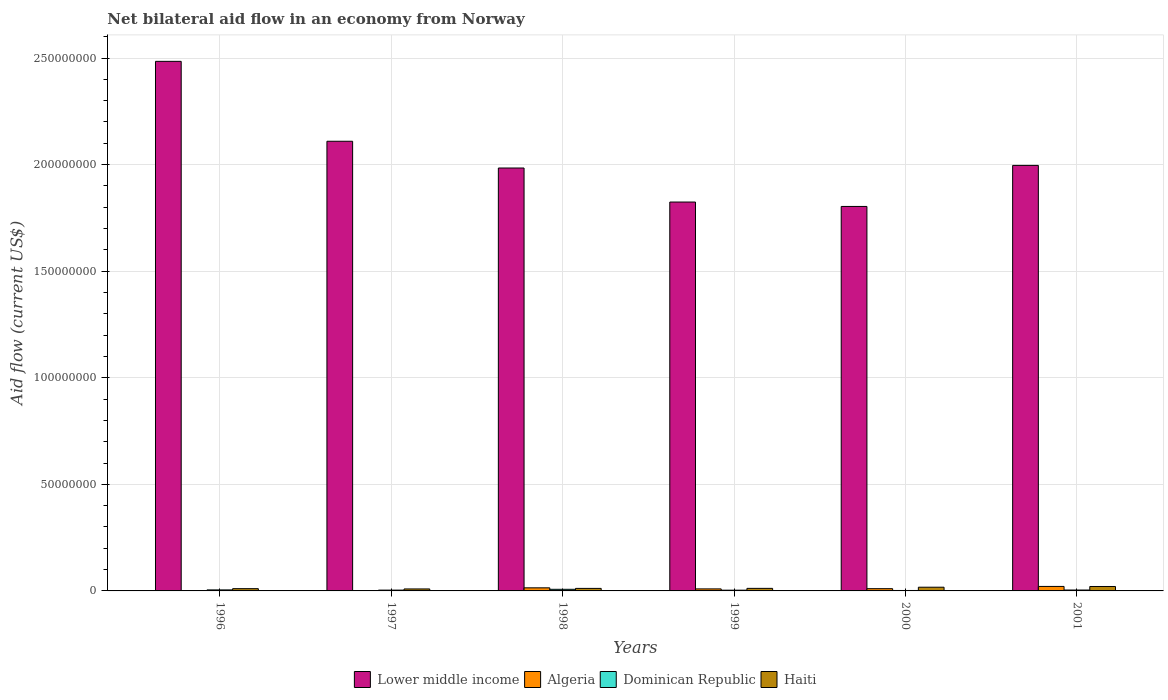How many groups of bars are there?
Your answer should be compact. 6. Are the number of bars per tick equal to the number of legend labels?
Make the answer very short. Yes. How many bars are there on the 6th tick from the left?
Give a very brief answer. 4. What is the label of the 2nd group of bars from the left?
Give a very brief answer. 1997. In how many cases, is the number of bars for a given year not equal to the number of legend labels?
Your answer should be very brief. 0. What is the net bilateral aid flow in Haiti in 1999?
Your response must be concise. 1.20e+06. Across all years, what is the maximum net bilateral aid flow in Haiti?
Make the answer very short. 2.08e+06. In which year was the net bilateral aid flow in Haiti maximum?
Keep it short and to the point. 2001. What is the total net bilateral aid flow in Lower middle income in the graph?
Offer a terse response. 1.22e+09. What is the difference between the net bilateral aid flow in Lower middle income in 1997 and that in 1998?
Keep it short and to the point. 1.26e+07. What is the difference between the net bilateral aid flow in Lower middle income in 2000 and the net bilateral aid flow in Algeria in 1998?
Your answer should be very brief. 1.79e+08. What is the average net bilateral aid flow in Lower middle income per year?
Your answer should be compact. 2.03e+08. In the year 1998, what is the difference between the net bilateral aid flow in Lower middle income and net bilateral aid flow in Haiti?
Ensure brevity in your answer.  1.97e+08. In how many years, is the net bilateral aid flow in Haiti greater than 150000000 US$?
Offer a terse response. 0. What is the ratio of the net bilateral aid flow in Lower middle income in 1997 to that in 1998?
Ensure brevity in your answer.  1.06. What is the difference between the highest and the second highest net bilateral aid flow in Algeria?
Offer a terse response. 6.60e+05. What is the difference between the highest and the lowest net bilateral aid flow in Algeria?
Offer a terse response. 2.01e+06. In how many years, is the net bilateral aid flow in Algeria greater than the average net bilateral aid flow in Algeria taken over all years?
Offer a terse response. 3. What does the 4th bar from the left in 1997 represents?
Provide a short and direct response. Haiti. What does the 3rd bar from the right in 1998 represents?
Ensure brevity in your answer.  Algeria. How many bars are there?
Give a very brief answer. 24. Are all the bars in the graph horizontal?
Offer a very short reply. No. Are the values on the major ticks of Y-axis written in scientific E-notation?
Your answer should be very brief. No. Does the graph contain any zero values?
Ensure brevity in your answer.  No. Does the graph contain grids?
Provide a succinct answer. Yes. How are the legend labels stacked?
Your response must be concise. Horizontal. What is the title of the graph?
Keep it short and to the point. Net bilateral aid flow in an economy from Norway. What is the label or title of the X-axis?
Your answer should be very brief. Years. What is the label or title of the Y-axis?
Keep it short and to the point. Aid flow (current US$). What is the Aid flow (current US$) in Lower middle income in 1996?
Make the answer very short. 2.48e+08. What is the Aid flow (current US$) of Dominican Republic in 1996?
Your answer should be very brief. 4.80e+05. What is the Aid flow (current US$) in Haiti in 1996?
Give a very brief answer. 1.06e+06. What is the Aid flow (current US$) in Lower middle income in 1997?
Give a very brief answer. 2.11e+08. What is the Aid flow (current US$) in Dominican Republic in 1997?
Provide a succinct answer. 3.80e+05. What is the Aid flow (current US$) in Haiti in 1997?
Keep it short and to the point. 9.30e+05. What is the Aid flow (current US$) in Lower middle income in 1998?
Your answer should be compact. 1.98e+08. What is the Aid flow (current US$) of Algeria in 1998?
Make the answer very short. 1.45e+06. What is the Aid flow (current US$) of Dominican Republic in 1998?
Your answer should be very brief. 7.60e+05. What is the Aid flow (current US$) in Haiti in 1998?
Offer a very short reply. 1.18e+06. What is the Aid flow (current US$) of Lower middle income in 1999?
Offer a very short reply. 1.82e+08. What is the Aid flow (current US$) in Algeria in 1999?
Provide a short and direct response. 9.50e+05. What is the Aid flow (current US$) in Haiti in 1999?
Keep it short and to the point. 1.20e+06. What is the Aid flow (current US$) of Lower middle income in 2000?
Make the answer very short. 1.80e+08. What is the Aid flow (current US$) of Algeria in 2000?
Ensure brevity in your answer.  1.05e+06. What is the Aid flow (current US$) in Dominican Republic in 2000?
Your response must be concise. 2.10e+05. What is the Aid flow (current US$) in Haiti in 2000?
Make the answer very short. 1.74e+06. What is the Aid flow (current US$) of Lower middle income in 2001?
Ensure brevity in your answer.  2.00e+08. What is the Aid flow (current US$) of Algeria in 2001?
Provide a short and direct response. 2.11e+06. What is the Aid flow (current US$) in Dominican Republic in 2001?
Offer a terse response. 4.20e+05. What is the Aid flow (current US$) in Haiti in 2001?
Provide a short and direct response. 2.08e+06. Across all years, what is the maximum Aid flow (current US$) of Lower middle income?
Keep it short and to the point. 2.48e+08. Across all years, what is the maximum Aid flow (current US$) of Algeria?
Keep it short and to the point. 2.11e+06. Across all years, what is the maximum Aid flow (current US$) in Dominican Republic?
Keep it short and to the point. 7.60e+05. Across all years, what is the maximum Aid flow (current US$) of Haiti?
Your answer should be compact. 2.08e+06. Across all years, what is the minimum Aid flow (current US$) in Lower middle income?
Your answer should be compact. 1.80e+08. Across all years, what is the minimum Aid flow (current US$) of Algeria?
Make the answer very short. 1.00e+05. Across all years, what is the minimum Aid flow (current US$) in Haiti?
Your answer should be compact. 9.30e+05. What is the total Aid flow (current US$) of Lower middle income in the graph?
Offer a very short reply. 1.22e+09. What is the total Aid flow (current US$) in Algeria in the graph?
Provide a short and direct response. 5.81e+06. What is the total Aid flow (current US$) in Dominican Republic in the graph?
Offer a very short reply. 2.60e+06. What is the total Aid flow (current US$) of Haiti in the graph?
Keep it short and to the point. 8.19e+06. What is the difference between the Aid flow (current US$) of Lower middle income in 1996 and that in 1997?
Keep it short and to the point. 3.75e+07. What is the difference between the Aid flow (current US$) in Algeria in 1996 and that in 1997?
Your answer should be very brief. 5.00e+04. What is the difference between the Aid flow (current US$) of Dominican Republic in 1996 and that in 1997?
Your answer should be compact. 1.00e+05. What is the difference between the Aid flow (current US$) of Haiti in 1996 and that in 1997?
Your response must be concise. 1.30e+05. What is the difference between the Aid flow (current US$) in Lower middle income in 1996 and that in 1998?
Offer a very short reply. 5.00e+07. What is the difference between the Aid flow (current US$) in Algeria in 1996 and that in 1998?
Offer a terse response. -1.30e+06. What is the difference between the Aid flow (current US$) of Dominican Republic in 1996 and that in 1998?
Provide a succinct answer. -2.80e+05. What is the difference between the Aid flow (current US$) of Lower middle income in 1996 and that in 1999?
Offer a very short reply. 6.60e+07. What is the difference between the Aid flow (current US$) of Algeria in 1996 and that in 1999?
Offer a terse response. -8.00e+05. What is the difference between the Aid flow (current US$) of Dominican Republic in 1996 and that in 1999?
Your answer should be compact. 1.30e+05. What is the difference between the Aid flow (current US$) in Haiti in 1996 and that in 1999?
Your answer should be very brief. -1.40e+05. What is the difference between the Aid flow (current US$) in Lower middle income in 1996 and that in 2000?
Ensure brevity in your answer.  6.81e+07. What is the difference between the Aid flow (current US$) in Algeria in 1996 and that in 2000?
Ensure brevity in your answer.  -9.00e+05. What is the difference between the Aid flow (current US$) of Haiti in 1996 and that in 2000?
Provide a short and direct response. -6.80e+05. What is the difference between the Aid flow (current US$) of Lower middle income in 1996 and that in 2001?
Ensure brevity in your answer.  4.88e+07. What is the difference between the Aid flow (current US$) of Algeria in 1996 and that in 2001?
Give a very brief answer. -1.96e+06. What is the difference between the Aid flow (current US$) of Haiti in 1996 and that in 2001?
Provide a succinct answer. -1.02e+06. What is the difference between the Aid flow (current US$) in Lower middle income in 1997 and that in 1998?
Give a very brief answer. 1.26e+07. What is the difference between the Aid flow (current US$) in Algeria in 1997 and that in 1998?
Offer a terse response. -1.35e+06. What is the difference between the Aid flow (current US$) of Dominican Republic in 1997 and that in 1998?
Give a very brief answer. -3.80e+05. What is the difference between the Aid flow (current US$) in Haiti in 1997 and that in 1998?
Ensure brevity in your answer.  -2.50e+05. What is the difference between the Aid flow (current US$) of Lower middle income in 1997 and that in 1999?
Give a very brief answer. 2.85e+07. What is the difference between the Aid flow (current US$) of Algeria in 1997 and that in 1999?
Give a very brief answer. -8.50e+05. What is the difference between the Aid flow (current US$) in Lower middle income in 1997 and that in 2000?
Provide a short and direct response. 3.06e+07. What is the difference between the Aid flow (current US$) of Algeria in 1997 and that in 2000?
Provide a short and direct response. -9.50e+05. What is the difference between the Aid flow (current US$) in Dominican Republic in 1997 and that in 2000?
Make the answer very short. 1.70e+05. What is the difference between the Aid flow (current US$) in Haiti in 1997 and that in 2000?
Offer a terse response. -8.10e+05. What is the difference between the Aid flow (current US$) of Lower middle income in 1997 and that in 2001?
Ensure brevity in your answer.  1.13e+07. What is the difference between the Aid flow (current US$) of Algeria in 1997 and that in 2001?
Make the answer very short. -2.01e+06. What is the difference between the Aid flow (current US$) in Dominican Republic in 1997 and that in 2001?
Offer a very short reply. -4.00e+04. What is the difference between the Aid flow (current US$) in Haiti in 1997 and that in 2001?
Your answer should be very brief. -1.15e+06. What is the difference between the Aid flow (current US$) in Lower middle income in 1998 and that in 1999?
Offer a very short reply. 1.60e+07. What is the difference between the Aid flow (current US$) in Algeria in 1998 and that in 1999?
Give a very brief answer. 5.00e+05. What is the difference between the Aid flow (current US$) in Dominican Republic in 1998 and that in 1999?
Offer a terse response. 4.10e+05. What is the difference between the Aid flow (current US$) in Lower middle income in 1998 and that in 2000?
Provide a succinct answer. 1.80e+07. What is the difference between the Aid flow (current US$) of Algeria in 1998 and that in 2000?
Provide a short and direct response. 4.00e+05. What is the difference between the Aid flow (current US$) in Dominican Republic in 1998 and that in 2000?
Your response must be concise. 5.50e+05. What is the difference between the Aid flow (current US$) in Haiti in 1998 and that in 2000?
Offer a very short reply. -5.60e+05. What is the difference between the Aid flow (current US$) of Lower middle income in 1998 and that in 2001?
Offer a terse response. -1.23e+06. What is the difference between the Aid flow (current US$) of Algeria in 1998 and that in 2001?
Provide a succinct answer. -6.60e+05. What is the difference between the Aid flow (current US$) in Haiti in 1998 and that in 2001?
Make the answer very short. -9.00e+05. What is the difference between the Aid flow (current US$) of Lower middle income in 1999 and that in 2000?
Offer a terse response. 2.07e+06. What is the difference between the Aid flow (current US$) of Dominican Republic in 1999 and that in 2000?
Provide a succinct answer. 1.40e+05. What is the difference between the Aid flow (current US$) in Haiti in 1999 and that in 2000?
Make the answer very short. -5.40e+05. What is the difference between the Aid flow (current US$) in Lower middle income in 1999 and that in 2001?
Your answer should be compact. -1.72e+07. What is the difference between the Aid flow (current US$) in Algeria in 1999 and that in 2001?
Your answer should be very brief. -1.16e+06. What is the difference between the Aid flow (current US$) of Dominican Republic in 1999 and that in 2001?
Offer a terse response. -7.00e+04. What is the difference between the Aid flow (current US$) in Haiti in 1999 and that in 2001?
Your response must be concise. -8.80e+05. What is the difference between the Aid flow (current US$) of Lower middle income in 2000 and that in 2001?
Offer a very short reply. -1.93e+07. What is the difference between the Aid flow (current US$) in Algeria in 2000 and that in 2001?
Ensure brevity in your answer.  -1.06e+06. What is the difference between the Aid flow (current US$) of Haiti in 2000 and that in 2001?
Offer a terse response. -3.40e+05. What is the difference between the Aid flow (current US$) in Lower middle income in 1996 and the Aid flow (current US$) in Algeria in 1997?
Ensure brevity in your answer.  2.48e+08. What is the difference between the Aid flow (current US$) of Lower middle income in 1996 and the Aid flow (current US$) of Dominican Republic in 1997?
Make the answer very short. 2.48e+08. What is the difference between the Aid flow (current US$) of Lower middle income in 1996 and the Aid flow (current US$) of Haiti in 1997?
Your answer should be compact. 2.48e+08. What is the difference between the Aid flow (current US$) in Algeria in 1996 and the Aid flow (current US$) in Dominican Republic in 1997?
Provide a short and direct response. -2.30e+05. What is the difference between the Aid flow (current US$) of Algeria in 1996 and the Aid flow (current US$) of Haiti in 1997?
Give a very brief answer. -7.80e+05. What is the difference between the Aid flow (current US$) of Dominican Republic in 1996 and the Aid flow (current US$) of Haiti in 1997?
Your response must be concise. -4.50e+05. What is the difference between the Aid flow (current US$) in Lower middle income in 1996 and the Aid flow (current US$) in Algeria in 1998?
Provide a short and direct response. 2.47e+08. What is the difference between the Aid flow (current US$) in Lower middle income in 1996 and the Aid flow (current US$) in Dominican Republic in 1998?
Provide a succinct answer. 2.48e+08. What is the difference between the Aid flow (current US$) in Lower middle income in 1996 and the Aid flow (current US$) in Haiti in 1998?
Your response must be concise. 2.47e+08. What is the difference between the Aid flow (current US$) in Algeria in 1996 and the Aid flow (current US$) in Dominican Republic in 1998?
Provide a succinct answer. -6.10e+05. What is the difference between the Aid flow (current US$) of Algeria in 1996 and the Aid flow (current US$) of Haiti in 1998?
Give a very brief answer. -1.03e+06. What is the difference between the Aid flow (current US$) in Dominican Republic in 1996 and the Aid flow (current US$) in Haiti in 1998?
Ensure brevity in your answer.  -7.00e+05. What is the difference between the Aid flow (current US$) in Lower middle income in 1996 and the Aid flow (current US$) in Algeria in 1999?
Provide a short and direct response. 2.48e+08. What is the difference between the Aid flow (current US$) in Lower middle income in 1996 and the Aid flow (current US$) in Dominican Republic in 1999?
Your answer should be very brief. 2.48e+08. What is the difference between the Aid flow (current US$) of Lower middle income in 1996 and the Aid flow (current US$) of Haiti in 1999?
Your response must be concise. 2.47e+08. What is the difference between the Aid flow (current US$) in Algeria in 1996 and the Aid flow (current US$) in Dominican Republic in 1999?
Offer a terse response. -2.00e+05. What is the difference between the Aid flow (current US$) in Algeria in 1996 and the Aid flow (current US$) in Haiti in 1999?
Your answer should be very brief. -1.05e+06. What is the difference between the Aid flow (current US$) of Dominican Republic in 1996 and the Aid flow (current US$) of Haiti in 1999?
Ensure brevity in your answer.  -7.20e+05. What is the difference between the Aid flow (current US$) of Lower middle income in 1996 and the Aid flow (current US$) of Algeria in 2000?
Your answer should be very brief. 2.47e+08. What is the difference between the Aid flow (current US$) of Lower middle income in 1996 and the Aid flow (current US$) of Dominican Republic in 2000?
Give a very brief answer. 2.48e+08. What is the difference between the Aid flow (current US$) of Lower middle income in 1996 and the Aid flow (current US$) of Haiti in 2000?
Provide a short and direct response. 2.47e+08. What is the difference between the Aid flow (current US$) of Algeria in 1996 and the Aid flow (current US$) of Haiti in 2000?
Ensure brevity in your answer.  -1.59e+06. What is the difference between the Aid flow (current US$) of Dominican Republic in 1996 and the Aid flow (current US$) of Haiti in 2000?
Your answer should be very brief. -1.26e+06. What is the difference between the Aid flow (current US$) in Lower middle income in 1996 and the Aid flow (current US$) in Algeria in 2001?
Make the answer very short. 2.46e+08. What is the difference between the Aid flow (current US$) in Lower middle income in 1996 and the Aid flow (current US$) in Dominican Republic in 2001?
Keep it short and to the point. 2.48e+08. What is the difference between the Aid flow (current US$) of Lower middle income in 1996 and the Aid flow (current US$) of Haiti in 2001?
Your answer should be compact. 2.46e+08. What is the difference between the Aid flow (current US$) of Algeria in 1996 and the Aid flow (current US$) of Haiti in 2001?
Offer a very short reply. -1.93e+06. What is the difference between the Aid flow (current US$) in Dominican Republic in 1996 and the Aid flow (current US$) in Haiti in 2001?
Make the answer very short. -1.60e+06. What is the difference between the Aid flow (current US$) in Lower middle income in 1997 and the Aid flow (current US$) in Algeria in 1998?
Give a very brief answer. 2.10e+08. What is the difference between the Aid flow (current US$) in Lower middle income in 1997 and the Aid flow (current US$) in Dominican Republic in 1998?
Your answer should be very brief. 2.10e+08. What is the difference between the Aid flow (current US$) of Lower middle income in 1997 and the Aid flow (current US$) of Haiti in 1998?
Offer a very short reply. 2.10e+08. What is the difference between the Aid flow (current US$) of Algeria in 1997 and the Aid flow (current US$) of Dominican Republic in 1998?
Ensure brevity in your answer.  -6.60e+05. What is the difference between the Aid flow (current US$) in Algeria in 1997 and the Aid flow (current US$) in Haiti in 1998?
Your answer should be very brief. -1.08e+06. What is the difference between the Aid flow (current US$) of Dominican Republic in 1997 and the Aid flow (current US$) of Haiti in 1998?
Ensure brevity in your answer.  -8.00e+05. What is the difference between the Aid flow (current US$) of Lower middle income in 1997 and the Aid flow (current US$) of Algeria in 1999?
Your answer should be compact. 2.10e+08. What is the difference between the Aid flow (current US$) of Lower middle income in 1997 and the Aid flow (current US$) of Dominican Republic in 1999?
Your answer should be compact. 2.11e+08. What is the difference between the Aid flow (current US$) in Lower middle income in 1997 and the Aid flow (current US$) in Haiti in 1999?
Provide a short and direct response. 2.10e+08. What is the difference between the Aid flow (current US$) of Algeria in 1997 and the Aid flow (current US$) of Dominican Republic in 1999?
Keep it short and to the point. -2.50e+05. What is the difference between the Aid flow (current US$) of Algeria in 1997 and the Aid flow (current US$) of Haiti in 1999?
Your answer should be compact. -1.10e+06. What is the difference between the Aid flow (current US$) of Dominican Republic in 1997 and the Aid flow (current US$) of Haiti in 1999?
Your answer should be very brief. -8.20e+05. What is the difference between the Aid flow (current US$) in Lower middle income in 1997 and the Aid flow (current US$) in Algeria in 2000?
Your response must be concise. 2.10e+08. What is the difference between the Aid flow (current US$) of Lower middle income in 1997 and the Aid flow (current US$) of Dominican Republic in 2000?
Ensure brevity in your answer.  2.11e+08. What is the difference between the Aid flow (current US$) in Lower middle income in 1997 and the Aid flow (current US$) in Haiti in 2000?
Give a very brief answer. 2.09e+08. What is the difference between the Aid flow (current US$) in Algeria in 1997 and the Aid flow (current US$) in Dominican Republic in 2000?
Your response must be concise. -1.10e+05. What is the difference between the Aid flow (current US$) in Algeria in 1997 and the Aid flow (current US$) in Haiti in 2000?
Offer a very short reply. -1.64e+06. What is the difference between the Aid flow (current US$) of Dominican Republic in 1997 and the Aid flow (current US$) of Haiti in 2000?
Keep it short and to the point. -1.36e+06. What is the difference between the Aid flow (current US$) in Lower middle income in 1997 and the Aid flow (current US$) in Algeria in 2001?
Provide a short and direct response. 2.09e+08. What is the difference between the Aid flow (current US$) of Lower middle income in 1997 and the Aid flow (current US$) of Dominican Republic in 2001?
Provide a short and direct response. 2.11e+08. What is the difference between the Aid flow (current US$) of Lower middle income in 1997 and the Aid flow (current US$) of Haiti in 2001?
Provide a short and direct response. 2.09e+08. What is the difference between the Aid flow (current US$) of Algeria in 1997 and the Aid flow (current US$) of Dominican Republic in 2001?
Make the answer very short. -3.20e+05. What is the difference between the Aid flow (current US$) in Algeria in 1997 and the Aid flow (current US$) in Haiti in 2001?
Your answer should be very brief. -1.98e+06. What is the difference between the Aid flow (current US$) of Dominican Republic in 1997 and the Aid flow (current US$) of Haiti in 2001?
Provide a succinct answer. -1.70e+06. What is the difference between the Aid flow (current US$) in Lower middle income in 1998 and the Aid flow (current US$) in Algeria in 1999?
Offer a very short reply. 1.97e+08. What is the difference between the Aid flow (current US$) in Lower middle income in 1998 and the Aid flow (current US$) in Dominican Republic in 1999?
Keep it short and to the point. 1.98e+08. What is the difference between the Aid flow (current US$) in Lower middle income in 1998 and the Aid flow (current US$) in Haiti in 1999?
Provide a succinct answer. 1.97e+08. What is the difference between the Aid flow (current US$) in Algeria in 1998 and the Aid flow (current US$) in Dominican Republic in 1999?
Give a very brief answer. 1.10e+06. What is the difference between the Aid flow (current US$) of Algeria in 1998 and the Aid flow (current US$) of Haiti in 1999?
Make the answer very short. 2.50e+05. What is the difference between the Aid flow (current US$) of Dominican Republic in 1998 and the Aid flow (current US$) of Haiti in 1999?
Ensure brevity in your answer.  -4.40e+05. What is the difference between the Aid flow (current US$) of Lower middle income in 1998 and the Aid flow (current US$) of Algeria in 2000?
Your response must be concise. 1.97e+08. What is the difference between the Aid flow (current US$) of Lower middle income in 1998 and the Aid flow (current US$) of Dominican Republic in 2000?
Your answer should be compact. 1.98e+08. What is the difference between the Aid flow (current US$) of Lower middle income in 1998 and the Aid flow (current US$) of Haiti in 2000?
Make the answer very short. 1.97e+08. What is the difference between the Aid flow (current US$) of Algeria in 1998 and the Aid flow (current US$) of Dominican Republic in 2000?
Provide a short and direct response. 1.24e+06. What is the difference between the Aid flow (current US$) in Algeria in 1998 and the Aid flow (current US$) in Haiti in 2000?
Your response must be concise. -2.90e+05. What is the difference between the Aid flow (current US$) in Dominican Republic in 1998 and the Aid flow (current US$) in Haiti in 2000?
Offer a very short reply. -9.80e+05. What is the difference between the Aid flow (current US$) of Lower middle income in 1998 and the Aid flow (current US$) of Algeria in 2001?
Offer a terse response. 1.96e+08. What is the difference between the Aid flow (current US$) in Lower middle income in 1998 and the Aid flow (current US$) in Dominican Republic in 2001?
Give a very brief answer. 1.98e+08. What is the difference between the Aid flow (current US$) of Lower middle income in 1998 and the Aid flow (current US$) of Haiti in 2001?
Your answer should be very brief. 1.96e+08. What is the difference between the Aid flow (current US$) in Algeria in 1998 and the Aid flow (current US$) in Dominican Republic in 2001?
Keep it short and to the point. 1.03e+06. What is the difference between the Aid flow (current US$) in Algeria in 1998 and the Aid flow (current US$) in Haiti in 2001?
Make the answer very short. -6.30e+05. What is the difference between the Aid flow (current US$) in Dominican Republic in 1998 and the Aid flow (current US$) in Haiti in 2001?
Give a very brief answer. -1.32e+06. What is the difference between the Aid flow (current US$) in Lower middle income in 1999 and the Aid flow (current US$) in Algeria in 2000?
Make the answer very short. 1.81e+08. What is the difference between the Aid flow (current US$) of Lower middle income in 1999 and the Aid flow (current US$) of Dominican Republic in 2000?
Offer a very short reply. 1.82e+08. What is the difference between the Aid flow (current US$) in Lower middle income in 1999 and the Aid flow (current US$) in Haiti in 2000?
Offer a very short reply. 1.81e+08. What is the difference between the Aid flow (current US$) in Algeria in 1999 and the Aid flow (current US$) in Dominican Republic in 2000?
Offer a very short reply. 7.40e+05. What is the difference between the Aid flow (current US$) of Algeria in 1999 and the Aid flow (current US$) of Haiti in 2000?
Ensure brevity in your answer.  -7.90e+05. What is the difference between the Aid flow (current US$) of Dominican Republic in 1999 and the Aid flow (current US$) of Haiti in 2000?
Ensure brevity in your answer.  -1.39e+06. What is the difference between the Aid flow (current US$) of Lower middle income in 1999 and the Aid flow (current US$) of Algeria in 2001?
Make the answer very short. 1.80e+08. What is the difference between the Aid flow (current US$) in Lower middle income in 1999 and the Aid flow (current US$) in Dominican Republic in 2001?
Give a very brief answer. 1.82e+08. What is the difference between the Aid flow (current US$) in Lower middle income in 1999 and the Aid flow (current US$) in Haiti in 2001?
Offer a very short reply. 1.80e+08. What is the difference between the Aid flow (current US$) in Algeria in 1999 and the Aid flow (current US$) in Dominican Republic in 2001?
Offer a terse response. 5.30e+05. What is the difference between the Aid flow (current US$) in Algeria in 1999 and the Aid flow (current US$) in Haiti in 2001?
Keep it short and to the point. -1.13e+06. What is the difference between the Aid flow (current US$) of Dominican Republic in 1999 and the Aid flow (current US$) of Haiti in 2001?
Make the answer very short. -1.73e+06. What is the difference between the Aid flow (current US$) of Lower middle income in 2000 and the Aid flow (current US$) of Algeria in 2001?
Offer a very short reply. 1.78e+08. What is the difference between the Aid flow (current US$) in Lower middle income in 2000 and the Aid flow (current US$) in Dominican Republic in 2001?
Make the answer very short. 1.80e+08. What is the difference between the Aid flow (current US$) of Lower middle income in 2000 and the Aid flow (current US$) of Haiti in 2001?
Keep it short and to the point. 1.78e+08. What is the difference between the Aid flow (current US$) in Algeria in 2000 and the Aid flow (current US$) in Dominican Republic in 2001?
Offer a very short reply. 6.30e+05. What is the difference between the Aid flow (current US$) in Algeria in 2000 and the Aid flow (current US$) in Haiti in 2001?
Your response must be concise. -1.03e+06. What is the difference between the Aid flow (current US$) in Dominican Republic in 2000 and the Aid flow (current US$) in Haiti in 2001?
Ensure brevity in your answer.  -1.87e+06. What is the average Aid flow (current US$) of Lower middle income per year?
Make the answer very short. 2.03e+08. What is the average Aid flow (current US$) of Algeria per year?
Make the answer very short. 9.68e+05. What is the average Aid flow (current US$) in Dominican Republic per year?
Your response must be concise. 4.33e+05. What is the average Aid flow (current US$) of Haiti per year?
Provide a succinct answer. 1.36e+06. In the year 1996, what is the difference between the Aid flow (current US$) of Lower middle income and Aid flow (current US$) of Algeria?
Provide a short and direct response. 2.48e+08. In the year 1996, what is the difference between the Aid flow (current US$) of Lower middle income and Aid flow (current US$) of Dominican Republic?
Make the answer very short. 2.48e+08. In the year 1996, what is the difference between the Aid flow (current US$) of Lower middle income and Aid flow (current US$) of Haiti?
Offer a very short reply. 2.47e+08. In the year 1996, what is the difference between the Aid flow (current US$) in Algeria and Aid flow (current US$) in Dominican Republic?
Keep it short and to the point. -3.30e+05. In the year 1996, what is the difference between the Aid flow (current US$) of Algeria and Aid flow (current US$) of Haiti?
Offer a terse response. -9.10e+05. In the year 1996, what is the difference between the Aid flow (current US$) in Dominican Republic and Aid flow (current US$) in Haiti?
Keep it short and to the point. -5.80e+05. In the year 1997, what is the difference between the Aid flow (current US$) in Lower middle income and Aid flow (current US$) in Algeria?
Keep it short and to the point. 2.11e+08. In the year 1997, what is the difference between the Aid flow (current US$) in Lower middle income and Aid flow (current US$) in Dominican Republic?
Offer a terse response. 2.11e+08. In the year 1997, what is the difference between the Aid flow (current US$) of Lower middle income and Aid flow (current US$) of Haiti?
Your response must be concise. 2.10e+08. In the year 1997, what is the difference between the Aid flow (current US$) in Algeria and Aid flow (current US$) in Dominican Republic?
Make the answer very short. -2.80e+05. In the year 1997, what is the difference between the Aid flow (current US$) of Algeria and Aid flow (current US$) of Haiti?
Make the answer very short. -8.30e+05. In the year 1997, what is the difference between the Aid flow (current US$) in Dominican Republic and Aid flow (current US$) in Haiti?
Give a very brief answer. -5.50e+05. In the year 1998, what is the difference between the Aid flow (current US$) of Lower middle income and Aid flow (current US$) of Algeria?
Your answer should be compact. 1.97e+08. In the year 1998, what is the difference between the Aid flow (current US$) of Lower middle income and Aid flow (current US$) of Dominican Republic?
Keep it short and to the point. 1.98e+08. In the year 1998, what is the difference between the Aid flow (current US$) of Lower middle income and Aid flow (current US$) of Haiti?
Ensure brevity in your answer.  1.97e+08. In the year 1998, what is the difference between the Aid flow (current US$) of Algeria and Aid flow (current US$) of Dominican Republic?
Offer a terse response. 6.90e+05. In the year 1998, what is the difference between the Aid flow (current US$) in Dominican Republic and Aid flow (current US$) in Haiti?
Provide a short and direct response. -4.20e+05. In the year 1999, what is the difference between the Aid flow (current US$) in Lower middle income and Aid flow (current US$) in Algeria?
Offer a terse response. 1.82e+08. In the year 1999, what is the difference between the Aid flow (current US$) in Lower middle income and Aid flow (current US$) in Dominican Republic?
Keep it short and to the point. 1.82e+08. In the year 1999, what is the difference between the Aid flow (current US$) in Lower middle income and Aid flow (current US$) in Haiti?
Offer a terse response. 1.81e+08. In the year 1999, what is the difference between the Aid flow (current US$) of Algeria and Aid flow (current US$) of Dominican Republic?
Your response must be concise. 6.00e+05. In the year 1999, what is the difference between the Aid flow (current US$) of Algeria and Aid flow (current US$) of Haiti?
Your response must be concise. -2.50e+05. In the year 1999, what is the difference between the Aid flow (current US$) of Dominican Republic and Aid flow (current US$) of Haiti?
Your answer should be compact. -8.50e+05. In the year 2000, what is the difference between the Aid flow (current US$) in Lower middle income and Aid flow (current US$) in Algeria?
Make the answer very short. 1.79e+08. In the year 2000, what is the difference between the Aid flow (current US$) in Lower middle income and Aid flow (current US$) in Dominican Republic?
Offer a terse response. 1.80e+08. In the year 2000, what is the difference between the Aid flow (current US$) in Lower middle income and Aid flow (current US$) in Haiti?
Ensure brevity in your answer.  1.79e+08. In the year 2000, what is the difference between the Aid flow (current US$) of Algeria and Aid flow (current US$) of Dominican Republic?
Provide a succinct answer. 8.40e+05. In the year 2000, what is the difference between the Aid flow (current US$) in Algeria and Aid flow (current US$) in Haiti?
Offer a very short reply. -6.90e+05. In the year 2000, what is the difference between the Aid flow (current US$) in Dominican Republic and Aid flow (current US$) in Haiti?
Your answer should be compact. -1.53e+06. In the year 2001, what is the difference between the Aid flow (current US$) of Lower middle income and Aid flow (current US$) of Algeria?
Your response must be concise. 1.98e+08. In the year 2001, what is the difference between the Aid flow (current US$) of Lower middle income and Aid flow (current US$) of Dominican Republic?
Your response must be concise. 1.99e+08. In the year 2001, what is the difference between the Aid flow (current US$) in Lower middle income and Aid flow (current US$) in Haiti?
Make the answer very short. 1.98e+08. In the year 2001, what is the difference between the Aid flow (current US$) of Algeria and Aid flow (current US$) of Dominican Republic?
Your response must be concise. 1.69e+06. In the year 2001, what is the difference between the Aid flow (current US$) in Algeria and Aid flow (current US$) in Haiti?
Provide a succinct answer. 3.00e+04. In the year 2001, what is the difference between the Aid flow (current US$) of Dominican Republic and Aid flow (current US$) of Haiti?
Your answer should be very brief. -1.66e+06. What is the ratio of the Aid flow (current US$) of Lower middle income in 1996 to that in 1997?
Ensure brevity in your answer.  1.18. What is the ratio of the Aid flow (current US$) in Dominican Republic in 1996 to that in 1997?
Provide a succinct answer. 1.26. What is the ratio of the Aid flow (current US$) in Haiti in 1996 to that in 1997?
Keep it short and to the point. 1.14. What is the ratio of the Aid flow (current US$) of Lower middle income in 1996 to that in 1998?
Offer a very short reply. 1.25. What is the ratio of the Aid flow (current US$) in Algeria in 1996 to that in 1998?
Ensure brevity in your answer.  0.1. What is the ratio of the Aid flow (current US$) of Dominican Republic in 1996 to that in 1998?
Offer a terse response. 0.63. What is the ratio of the Aid flow (current US$) of Haiti in 1996 to that in 1998?
Provide a short and direct response. 0.9. What is the ratio of the Aid flow (current US$) in Lower middle income in 1996 to that in 1999?
Provide a short and direct response. 1.36. What is the ratio of the Aid flow (current US$) in Algeria in 1996 to that in 1999?
Provide a succinct answer. 0.16. What is the ratio of the Aid flow (current US$) in Dominican Republic in 1996 to that in 1999?
Offer a terse response. 1.37. What is the ratio of the Aid flow (current US$) in Haiti in 1996 to that in 1999?
Give a very brief answer. 0.88. What is the ratio of the Aid flow (current US$) in Lower middle income in 1996 to that in 2000?
Keep it short and to the point. 1.38. What is the ratio of the Aid flow (current US$) in Algeria in 1996 to that in 2000?
Ensure brevity in your answer.  0.14. What is the ratio of the Aid flow (current US$) of Dominican Republic in 1996 to that in 2000?
Your response must be concise. 2.29. What is the ratio of the Aid flow (current US$) in Haiti in 1996 to that in 2000?
Keep it short and to the point. 0.61. What is the ratio of the Aid flow (current US$) of Lower middle income in 1996 to that in 2001?
Give a very brief answer. 1.24. What is the ratio of the Aid flow (current US$) in Algeria in 1996 to that in 2001?
Ensure brevity in your answer.  0.07. What is the ratio of the Aid flow (current US$) in Dominican Republic in 1996 to that in 2001?
Your response must be concise. 1.14. What is the ratio of the Aid flow (current US$) of Haiti in 1996 to that in 2001?
Offer a terse response. 0.51. What is the ratio of the Aid flow (current US$) in Lower middle income in 1997 to that in 1998?
Give a very brief answer. 1.06. What is the ratio of the Aid flow (current US$) of Algeria in 1997 to that in 1998?
Your answer should be compact. 0.07. What is the ratio of the Aid flow (current US$) of Dominican Republic in 1997 to that in 1998?
Keep it short and to the point. 0.5. What is the ratio of the Aid flow (current US$) in Haiti in 1997 to that in 1998?
Provide a short and direct response. 0.79. What is the ratio of the Aid flow (current US$) in Lower middle income in 1997 to that in 1999?
Offer a terse response. 1.16. What is the ratio of the Aid flow (current US$) in Algeria in 1997 to that in 1999?
Your response must be concise. 0.11. What is the ratio of the Aid flow (current US$) of Dominican Republic in 1997 to that in 1999?
Give a very brief answer. 1.09. What is the ratio of the Aid flow (current US$) of Haiti in 1997 to that in 1999?
Give a very brief answer. 0.78. What is the ratio of the Aid flow (current US$) in Lower middle income in 1997 to that in 2000?
Make the answer very short. 1.17. What is the ratio of the Aid flow (current US$) in Algeria in 1997 to that in 2000?
Your response must be concise. 0.1. What is the ratio of the Aid flow (current US$) in Dominican Republic in 1997 to that in 2000?
Make the answer very short. 1.81. What is the ratio of the Aid flow (current US$) in Haiti in 1997 to that in 2000?
Provide a succinct answer. 0.53. What is the ratio of the Aid flow (current US$) in Lower middle income in 1997 to that in 2001?
Give a very brief answer. 1.06. What is the ratio of the Aid flow (current US$) in Algeria in 1997 to that in 2001?
Provide a succinct answer. 0.05. What is the ratio of the Aid flow (current US$) of Dominican Republic in 1997 to that in 2001?
Your response must be concise. 0.9. What is the ratio of the Aid flow (current US$) in Haiti in 1997 to that in 2001?
Your answer should be compact. 0.45. What is the ratio of the Aid flow (current US$) in Lower middle income in 1998 to that in 1999?
Your response must be concise. 1.09. What is the ratio of the Aid flow (current US$) in Algeria in 1998 to that in 1999?
Your answer should be very brief. 1.53. What is the ratio of the Aid flow (current US$) of Dominican Republic in 1998 to that in 1999?
Make the answer very short. 2.17. What is the ratio of the Aid flow (current US$) of Haiti in 1998 to that in 1999?
Your answer should be very brief. 0.98. What is the ratio of the Aid flow (current US$) in Lower middle income in 1998 to that in 2000?
Offer a terse response. 1.1. What is the ratio of the Aid flow (current US$) of Algeria in 1998 to that in 2000?
Your response must be concise. 1.38. What is the ratio of the Aid flow (current US$) in Dominican Republic in 1998 to that in 2000?
Give a very brief answer. 3.62. What is the ratio of the Aid flow (current US$) in Haiti in 1998 to that in 2000?
Offer a very short reply. 0.68. What is the ratio of the Aid flow (current US$) in Algeria in 1998 to that in 2001?
Your answer should be very brief. 0.69. What is the ratio of the Aid flow (current US$) in Dominican Republic in 1998 to that in 2001?
Your answer should be compact. 1.81. What is the ratio of the Aid flow (current US$) of Haiti in 1998 to that in 2001?
Your answer should be very brief. 0.57. What is the ratio of the Aid flow (current US$) in Lower middle income in 1999 to that in 2000?
Offer a terse response. 1.01. What is the ratio of the Aid flow (current US$) of Algeria in 1999 to that in 2000?
Offer a terse response. 0.9. What is the ratio of the Aid flow (current US$) in Dominican Republic in 1999 to that in 2000?
Offer a very short reply. 1.67. What is the ratio of the Aid flow (current US$) in Haiti in 1999 to that in 2000?
Keep it short and to the point. 0.69. What is the ratio of the Aid flow (current US$) in Lower middle income in 1999 to that in 2001?
Your response must be concise. 0.91. What is the ratio of the Aid flow (current US$) of Algeria in 1999 to that in 2001?
Offer a terse response. 0.45. What is the ratio of the Aid flow (current US$) in Dominican Republic in 1999 to that in 2001?
Ensure brevity in your answer.  0.83. What is the ratio of the Aid flow (current US$) in Haiti in 1999 to that in 2001?
Keep it short and to the point. 0.58. What is the ratio of the Aid flow (current US$) of Lower middle income in 2000 to that in 2001?
Your answer should be compact. 0.9. What is the ratio of the Aid flow (current US$) of Algeria in 2000 to that in 2001?
Provide a short and direct response. 0.5. What is the ratio of the Aid flow (current US$) in Haiti in 2000 to that in 2001?
Offer a very short reply. 0.84. What is the difference between the highest and the second highest Aid flow (current US$) in Lower middle income?
Your answer should be very brief. 3.75e+07. What is the difference between the highest and the second highest Aid flow (current US$) in Algeria?
Give a very brief answer. 6.60e+05. What is the difference between the highest and the second highest Aid flow (current US$) of Dominican Republic?
Offer a terse response. 2.80e+05. What is the difference between the highest and the lowest Aid flow (current US$) of Lower middle income?
Provide a succinct answer. 6.81e+07. What is the difference between the highest and the lowest Aid flow (current US$) of Algeria?
Your response must be concise. 2.01e+06. What is the difference between the highest and the lowest Aid flow (current US$) of Haiti?
Keep it short and to the point. 1.15e+06. 